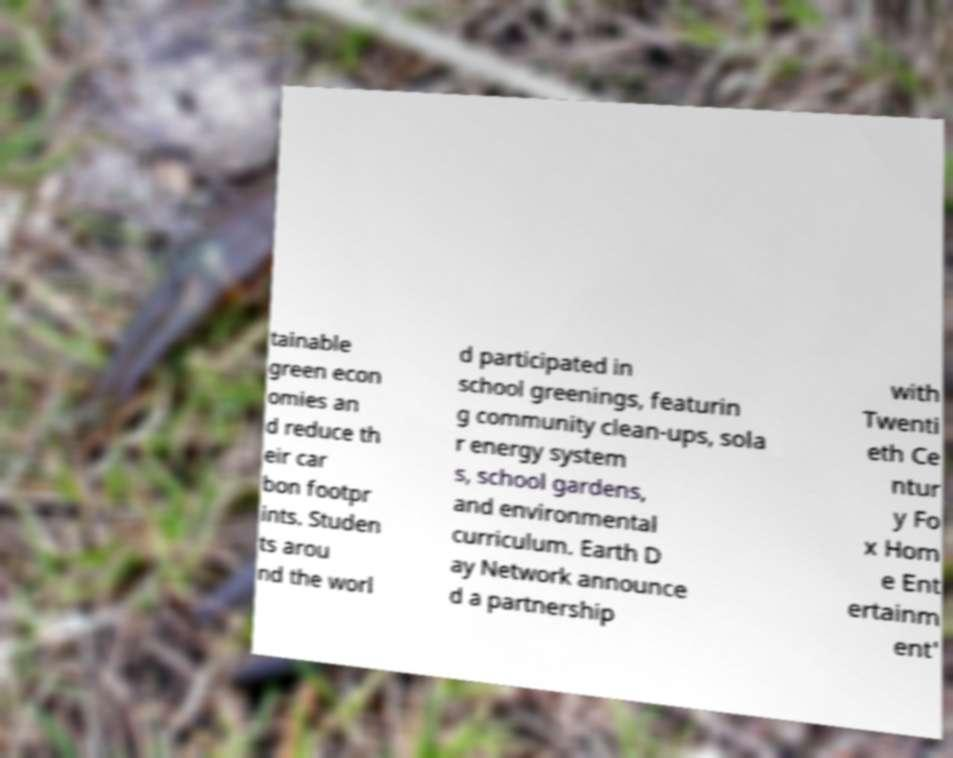Please read and relay the text visible in this image. What does it say? tainable green econ omies an d reduce th eir car bon footpr ints. Studen ts arou nd the worl d participated in school greenings, featurin g community clean-ups, sola r energy system s, school gardens, and environmental curriculum. Earth D ay Network announce d a partnership with Twenti eth Ce ntur y Fo x Hom e Ent ertainm ent' 